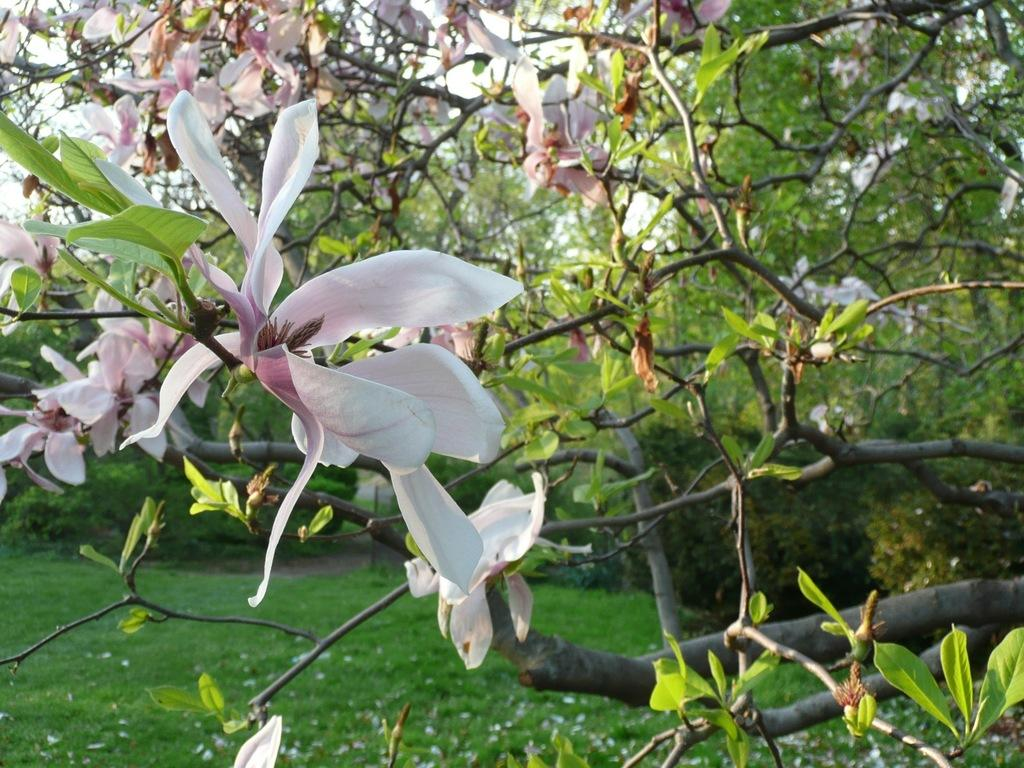What type of plant is the main subject in the image? There is a flower tree in the image. What can be seen in the background of the image? There are shrubs, trees, and grass in the background of the image. Can you tell me how many cats are sitting on the plane in the image? There are no cats or planes present in the image; it features a flower tree and background elements. 